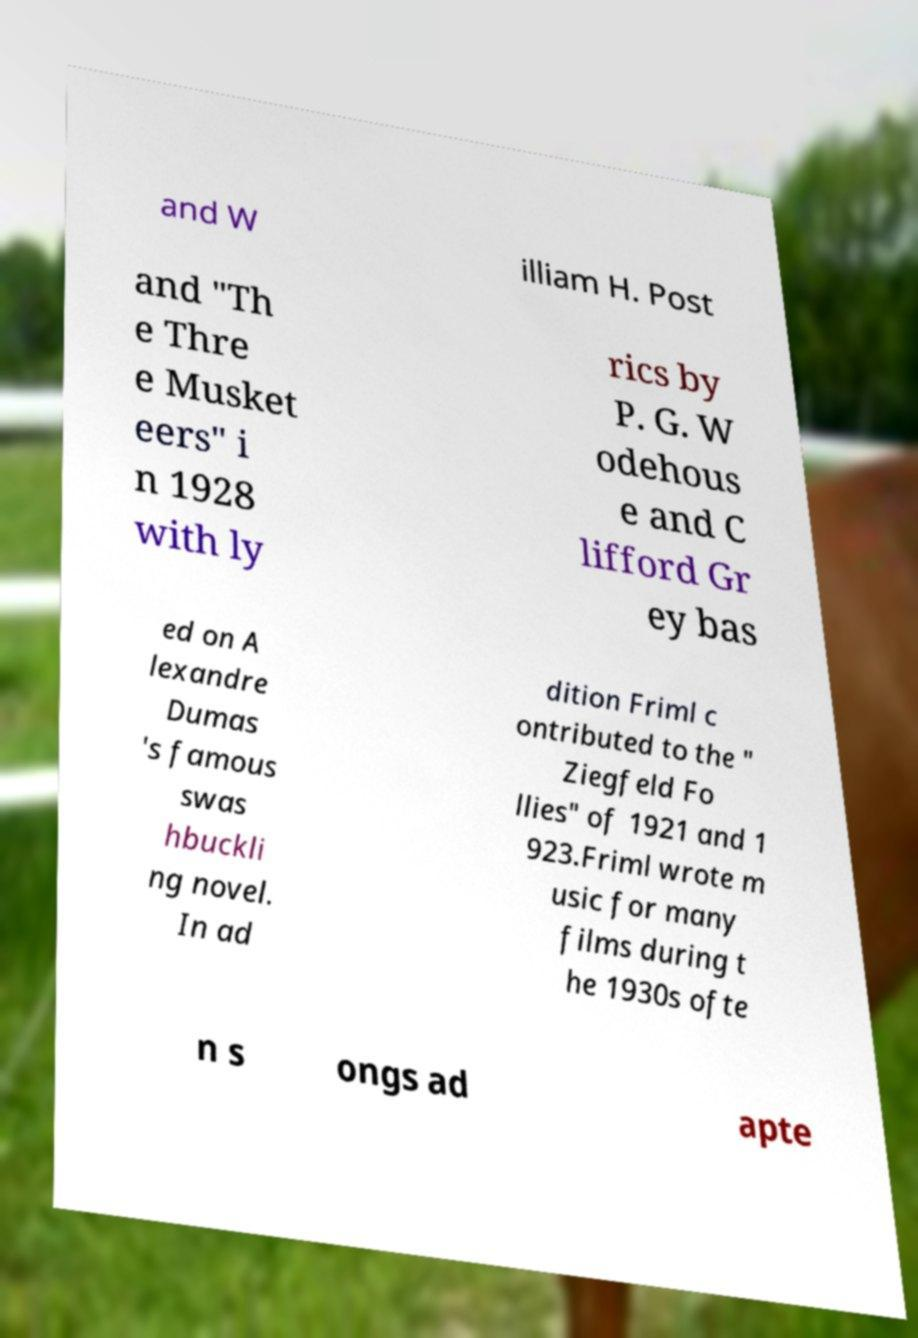I need the written content from this picture converted into text. Can you do that? and W illiam H. Post and "Th e Thre e Musket eers" i n 1928 with ly rics by P. G. W odehous e and C lifford Gr ey bas ed on A lexandre Dumas 's famous swas hbuckli ng novel. In ad dition Friml c ontributed to the " Ziegfeld Fo llies" of 1921 and 1 923.Friml wrote m usic for many films during t he 1930s ofte n s ongs ad apte 